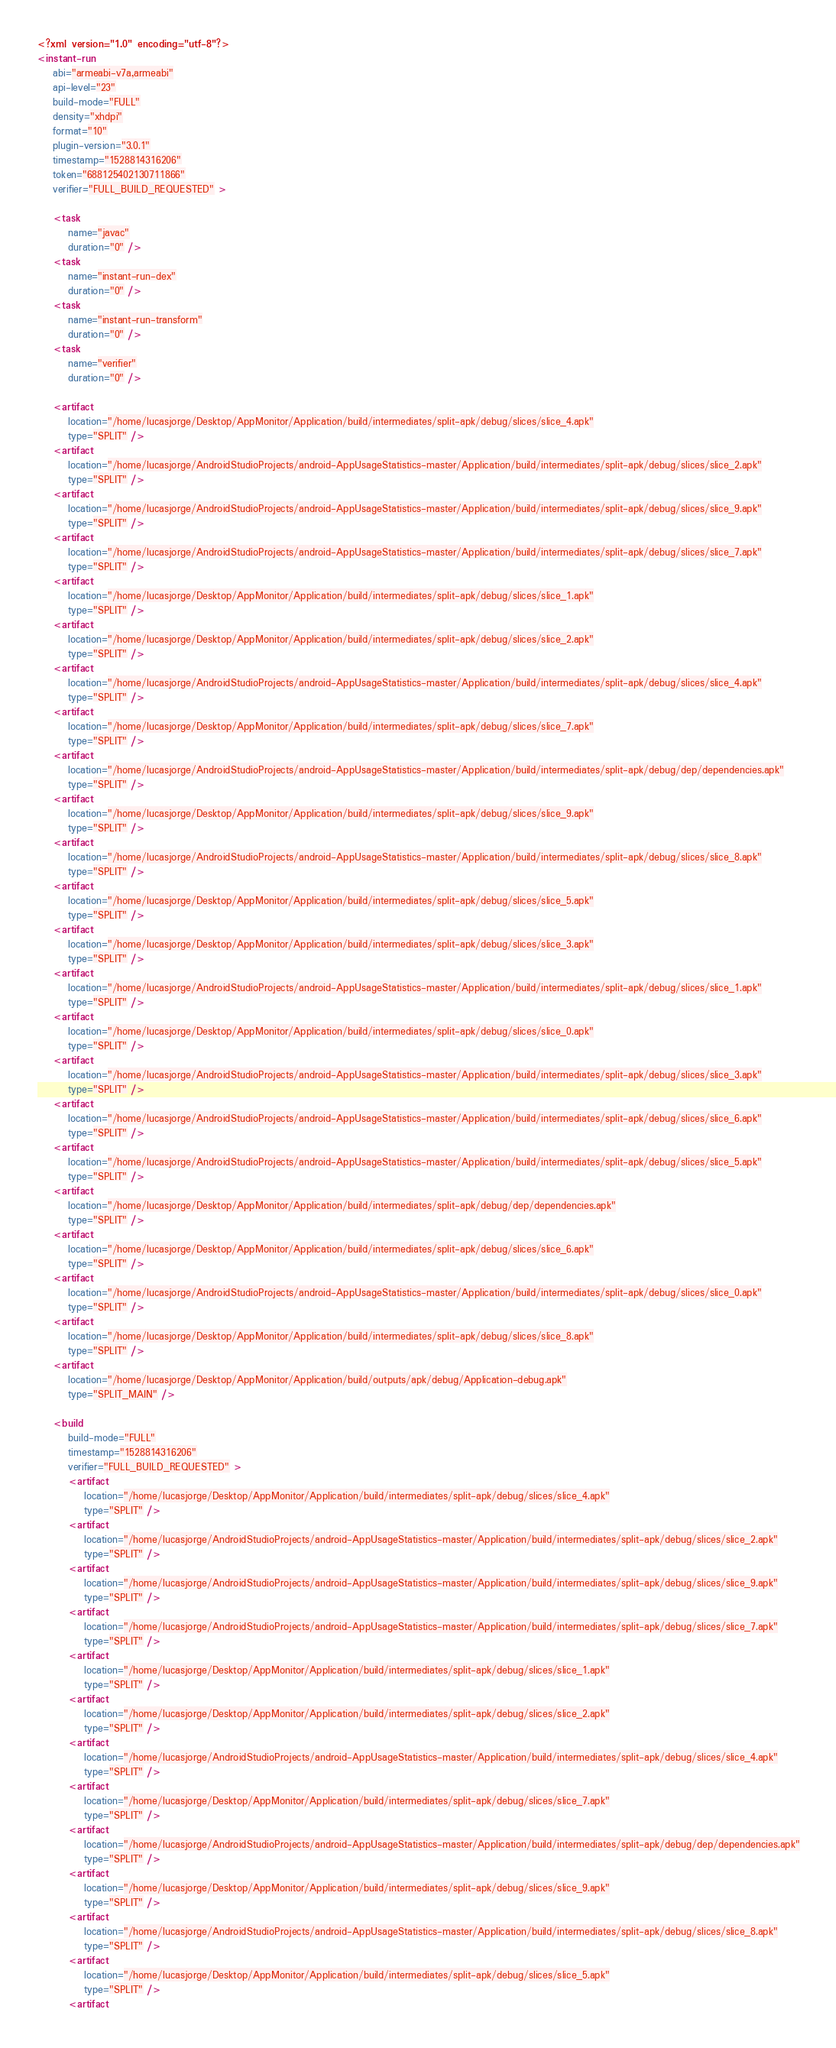<code> <loc_0><loc_0><loc_500><loc_500><_XML_><?xml version="1.0" encoding="utf-8"?>
<instant-run
    abi="armeabi-v7a,armeabi"
    api-level="23"
    build-mode="FULL"
    density="xhdpi"
    format="10"
    plugin-version="3.0.1"
    timestamp="1528814316206"
    token="688125402130711866"
    verifier="FULL_BUILD_REQUESTED" >

    <task
        name="javac"
        duration="0" />
    <task
        name="instant-run-dex"
        duration="0" />
    <task
        name="instant-run-transform"
        duration="0" />
    <task
        name="verifier"
        duration="0" />

    <artifact
        location="/home/lucasjorge/Desktop/AppMonitor/Application/build/intermediates/split-apk/debug/slices/slice_4.apk"
        type="SPLIT" />
    <artifact
        location="/home/lucasjorge/AndroidStudioProjects/android-AppUsageStatistics-master/Application/build/intermediates/split-apk/debug/slices/slice_2.apk"
        type="SPLIT" />
    <artifact
        location="/home/lucasjorge/AndroidStudioProjects/android-AppUsageStatistics-master/Application/build/intermediates/split-apk/debug/slices/slice_9.apk"
        type="SPLIT" />
    <artifact
        location="/home/lucasjorge/AndroidStudioProjects/android-AppUsageStatistics-master/Application/build/intermediates/split-apk/debug/slices/slice_7.apk"
        type="SPLIT" />
    <artifact
        location="/home/lucasjorge/Desktop/AppMonitor/Application/build/intermediates/split-apk/debug/slices/slice_1.apk"
        type="SPLIT" />
    <artifact
        location="/home/lucasjorge/Desktop/AppMonitor/Application/build/intermediates/split-apk/debug/slices/slice_2.apk"
        type="SPLIT" />
    <artifact
        location="/home/lucasjorge/AndroidStudioProjects/android-AppUsageStatistics-master/Application/build/intermediates/split-apk/debug/slices/slice_4.apk"
        type="SPLIT" />
    <artifact
        location="/home/lucasjorge/Desktop/AppMonitor/Application/build/intermediates/split-apk/debug/slices/slice_7.apk"
        type="SPLIT" />
    <artifact
        location="/home/lucasjorge/AndroidStudioProjects/android-AppUsageStatistics-master/Application/build/intermediates/split-apk/debug/dep/dependencies.apk"
        type="SPLIT" />
    <artifact
        location="/home/lucasjorge/Desktop/AppMonitor/Application/build/intermediates/split-apk/debug/slices/slice_9.apk"
        type="SPLIT" />
    <artifact
        location="/home/lucasjorge/AndroidStudioProjects/android-AppUsageStatistics-master/Application/build/intermediates/split-apk/debug/slices/slice_8.apk"
        type="SPLIT" />
    <artifact
        location="/home/lucasjorge/Desktop/AppMonitor/Application/build/intermediates/split-apk/debug/slices/slice_5.apk"
        type="SPLIT" />
    <artifact
        location="/home/lucasjorge/Desktop/AppMonitor/Application/build/intermediates/split-apk/debug/slices/slice_3.apk"
        type="SPLIT" />
    <artifact
        location="/home/lucasjorge/AndroidStudioProjects/android-AppUsageStatistics-master/Application/build/intermediates/split-apk/debug/slices/slice_1.apk"
        type="SPLIT" />
    <artifact
        location="/home/lucasjorge/Desktop/AppMonitor/Application/build/intermediates/split-apk/debug/slices/slice_0.apk"
        type="SPLIT" />
    <artifact
        location="/home/lucasjorge/AndroidStudioProjects/android-AppUsageStatistics-master/Application/build/intermediates/split-apk/debug/slices/slice_3.apk"
        type="SPLIT" />
    <artifact
        location="/home/lucasjorge/AndroidStudioProjects/android-AppUsageStatistics-master/Application/build/intermediates/split-apk/debug/slices/slice_6.apk"
        type="SPLIT" />
    <artifact
        location="/home/lucasjorge/AndroidStudioProjects/android-AppUsageStatistics-master/Application/build/intermediates/split-apk/debug/slices/slice_5.apk"
        type="SPLIT" />
    <artifact
        location="/home/lucasjorge/Desktop/AppMonitor/Application/build/intermediates/split-apk/debug/dep/dependencies.apk"
        type="SPLIT" />
    <artifact
        location="/home/lucasjorge/Desktop/AppMonitor/Application/build/intermediates/split-apk/debug/slices/slice_6.apk"
        type="SPLIT" />
    <artifact
        location="/home/lucasjorge/AndroidStudioProjects/android-AppUsageStatistics-master/Application/build/intermediates/split-apk/debug/slices/slice_0.apk"
        type="SPLIT" />
    <artifact
        location="/home/lucasjorge/Desktop/AppMonitor/Application/build/intermediates/split-apk/debug/slices/slice_8.apk"
        type="SPLIT" />
    <artifact
        location="/home/lucasjorge/Desktop/AppMonitor/Application/build/outputs/apk/debug/Application-debug.apk"
        type="SPLIT_MAIN" />

    <build
        build-mode="FULL"
        timestamp="1528814316206"
        verifier="FULL_BUILD_REQUESTED" >
        <artifact
            location="/home/lucasjorge/Desktop/AppMonitor/Application/build/intermediates/split-apk/debug/slices/slice_4.apk"
            type="SPLIT" />
        <artifact
            location="/home/lucasjorge/AndroidStudioProjects/android-AppUsageStatistics-master/Application/build/intermediates/split-apk/debug/slices/slice_2.apk"
            type="SPLIT" />
        <artifact
            location="/home/lucasjorge/AndroidStudioProjects/android-AppUsageStatistics-master/Application/build/intermediates/split-apk/debug/slices/slice_9.apk"
            type="SPLIT" />
        <artifact
            location="/home/lucasjorge/AndroidStudioProjects/android-AppUsageStatistics-master/Application/build/intermediates/split-apk/debug/slices/slice_7.apk"
            type="SPLIT" />
        <artifact
            location="/home/lucasjorge/Desktop/AppMonitor/Application/build/intermediates/split-apk/debug/slices/slice_1.apk"
            type="SPLIT" />
        <artifact
            location="/home/lucasjorge/Desktop/AppMonitor/Application/build/intermediates/split-apk/debug/slices/slice_2.apk"
            type="SPLIT" />
        <artifact
            location="/home/lucasjorge/AndroidStudioProjects/android-AppUsageStatistics-master/Application/build/intermediates/split-apk/debug/slices/slice_4.apk"
            type="SPLIT" />
        <artifact
            location="/home/lucasjorge/Desktop/AppMonitor/Application/build/intermediates/split-apk/debug/slices/slice_7.apk"
            type="SPLIT" />
        <artifact
            location="/home/lucasjorge/AndroidStudioProjects/android-AppUsageStatistics-master/Application/build/intermediates/split-apk/debug/dep/dependencies.apk"
            type="SPLIT" />
        <artifact
            location="/home/lucasjorge/Desktop/AppMonitor/Application/build/intermediates/split-apk/debug/slices/slice_9.apk"
            type="SPLIT" />
        <artifact
            location="/home/lucasjorge/AndroidStudioProjects/android-AppUsageStatistics-master/Application/build/intermediates/split-apk/debug/slices/slice_8.apk"
            type="SPLIT" />
        <artifact
            location="/home/lucasjorge/Desktop/AppMonitor/Application/build/intermediates/split-apk/debug/slices/slice_5.apk"
            type="SPLIT" />
        <artifact</code> 